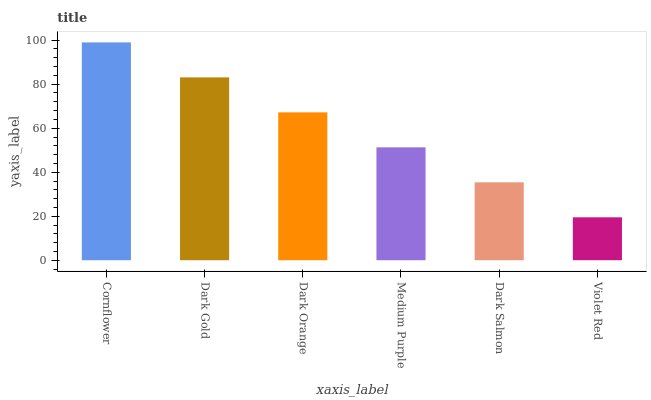Is Violet Red the minimum?
Answer yes or no. Yes. Is Cornflower the maximum?
Answer yes or no. Yes. Is Dark Gold the minimum?
Answer yes or no. No. Is Dark Gold the maximum?
Answer yes or no. No. Is Cornflower greater than Dark Gold?
Answer yes or no. Yes. Is Dark Gold less than Cornflower?
Answer yes or no. Yes. Is Dark Gold greater than Cornflower?
Answer yes or no. No. Is Cornflower less than Dark Gold?
Answer yes or no. No. Is Dark Orange the high median?
Answer yes or no. Yes. Is Medium Purple the low median?
Answer yes or no. Yes. Is Violet Red the high median?
Answer yes or no. No. Is Dark Orange the low median?
Answer yes or no. No. 